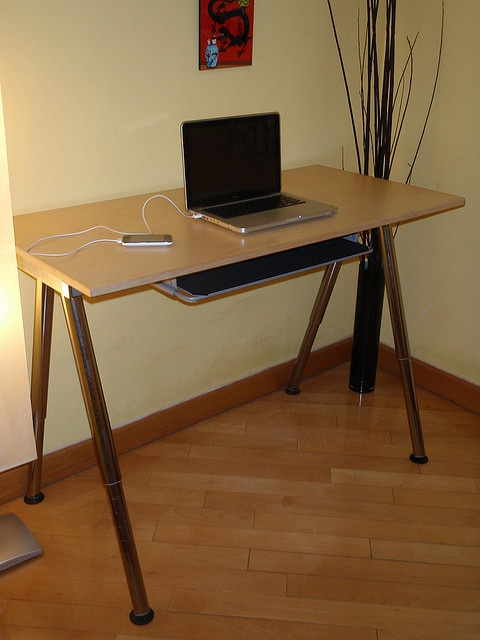Describe the objects in this image and their specific colors. I can see laptop in tan, black, and gray tones, keyboard in tan, black, gray, and blue tones, vase in tan, black, darkgreen, and olive tones, keyboard in tan, black, and gray tones, and cell phone in tan, olive, lightgray, and gray tones in this image. 